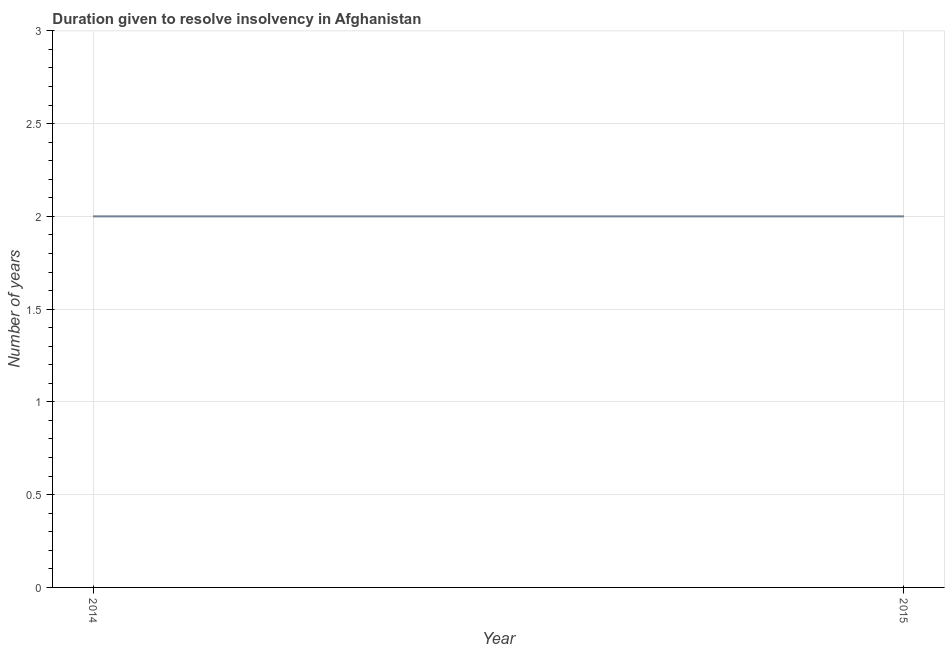What is the number of years to resolve insolvency in 2015?
Provide a succinct answer. 2. Across all years, what is the maximum number of years to resolve insolvency?
Offer a terse response. 2. Across all years, what is the minimum number of years to resolve insolvency?
Your answer should be compact. 2. In which year was the number of years to resolve insolvency maximum?
Provide a short and direct response. 2014. In which year was the number of years to resolve insolvency minimum?
Your answer should be very brief. 2014. What is the sum of the number of years to resolve insolvency?
Your answer should be very brief. 4. What is the average number of years to resolve insolvency per year?
Ensure brevity in your answer.  2. What is the median number of years to resolve insolvency?
Ensure brevity in your answer.  2. In how many years, is the number of years to resolve insolvency greater than 2.8 ?
Your answer should be very brief. 0. Do a majority of the years between 2015 and 2014 (inclusive) have number of years to resolve insolvency greater than 1.9 ?
Keep it short and to the point. No. What is the ratio of the number of years to resolve insolvency in 2014 to that in 2015?
Your answer should be compact. 1. In how many years, is the number of years to resolve insolvency greater than the average number of years to resolve insolvency taken over all years?
Give a very brief answer. 0. Does the number of years to resolve insolvency monotonically increase over the years?
Your response must be concise. No. How many lines are there?
Your response must be concise. 1. How many years are there in the graph?
Your answer should be compact. 2. What is the difference between two consecutive major ticks on the Y-axis?
Ensure brevity in your answer.  0.5. Are the values on the major ticks of Y-axis written in scientific E-notation?
Ensure brevity in your answer.  No. Does the graph contain any zero values?
Your response must be concise. No. Does the graph contain grids?
Provide a succinct answer. Yes. What is the title of the graph?
Your answer should be very brief. Duration given to resolve insolvency in Afghanistan. What is the label or title of the X-axis?
Your answer should be compact. Year. What is the label or title of the Y-axis?
Make the answer very short. Number of years. What is the Number of years in 2014?
Your response must be concise. 2. What is the difference between the Number of years in 2014 and 2015?
Make the answer very short. 0. 